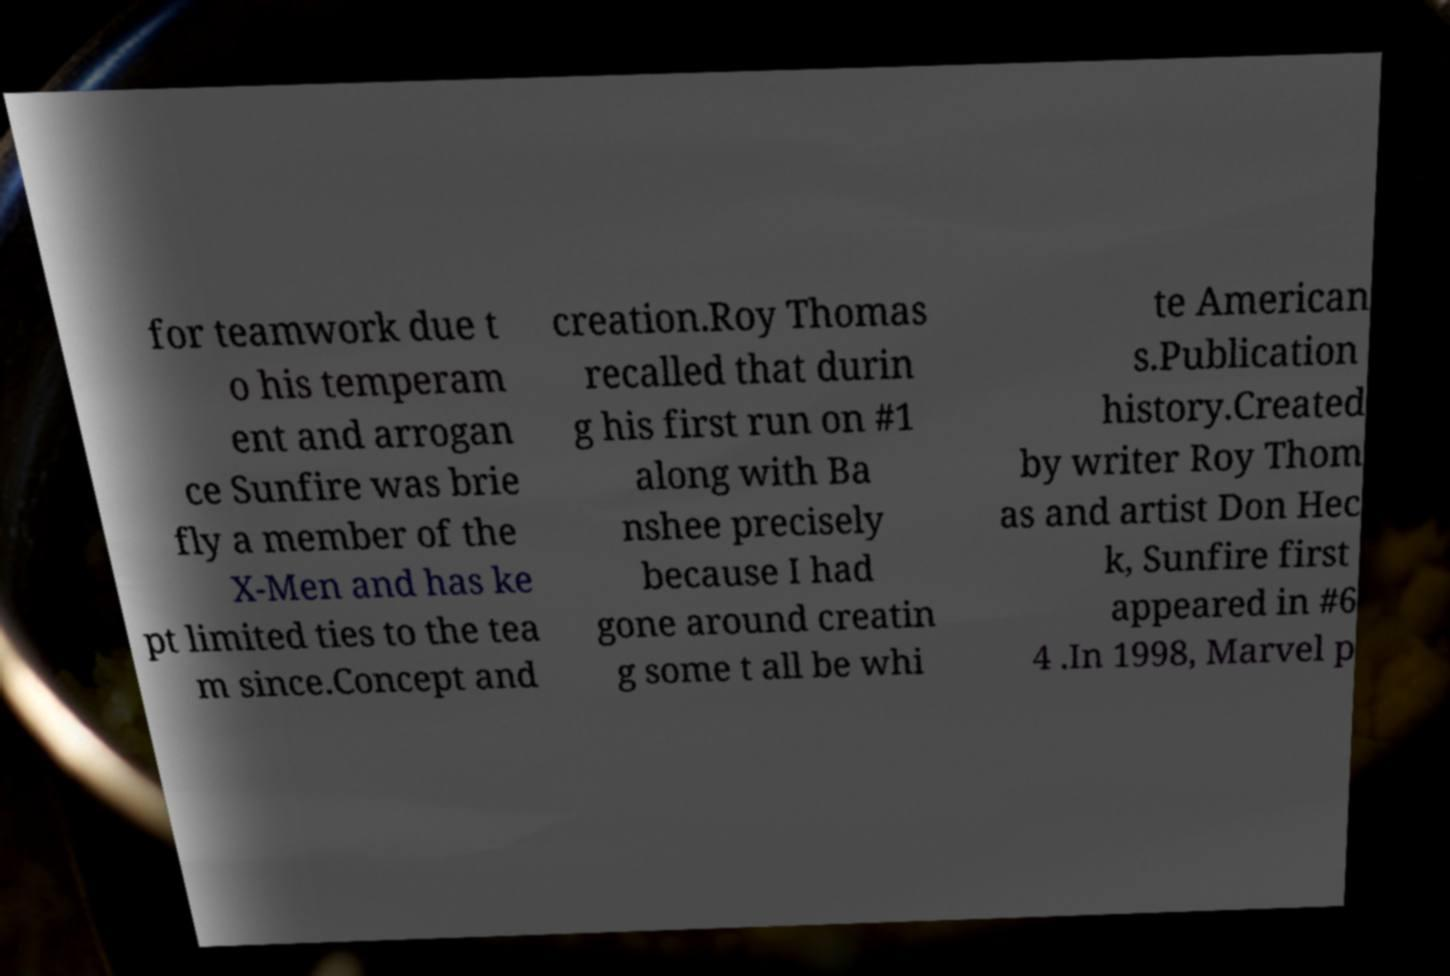Can you read and provide the text displayed in the image?This photo seems to have some interesting text. Can you extract and type it out for me? for teamwork due t o his temperam ent and arrogan ce Sunfire was brie fly a member of the X-Men and has ke pt limited ties to the tea m since.Concept and creation.Roy Thomas recalled that durin g his first run on #1 along with Ba nshee precisely because I had gone around creatin g some t all be whi te American s.Publication history.Created by writer Roy Thom as and artist Don Hec k, Sunfire first appeared in #6 4 .In 1998, Marvel p 